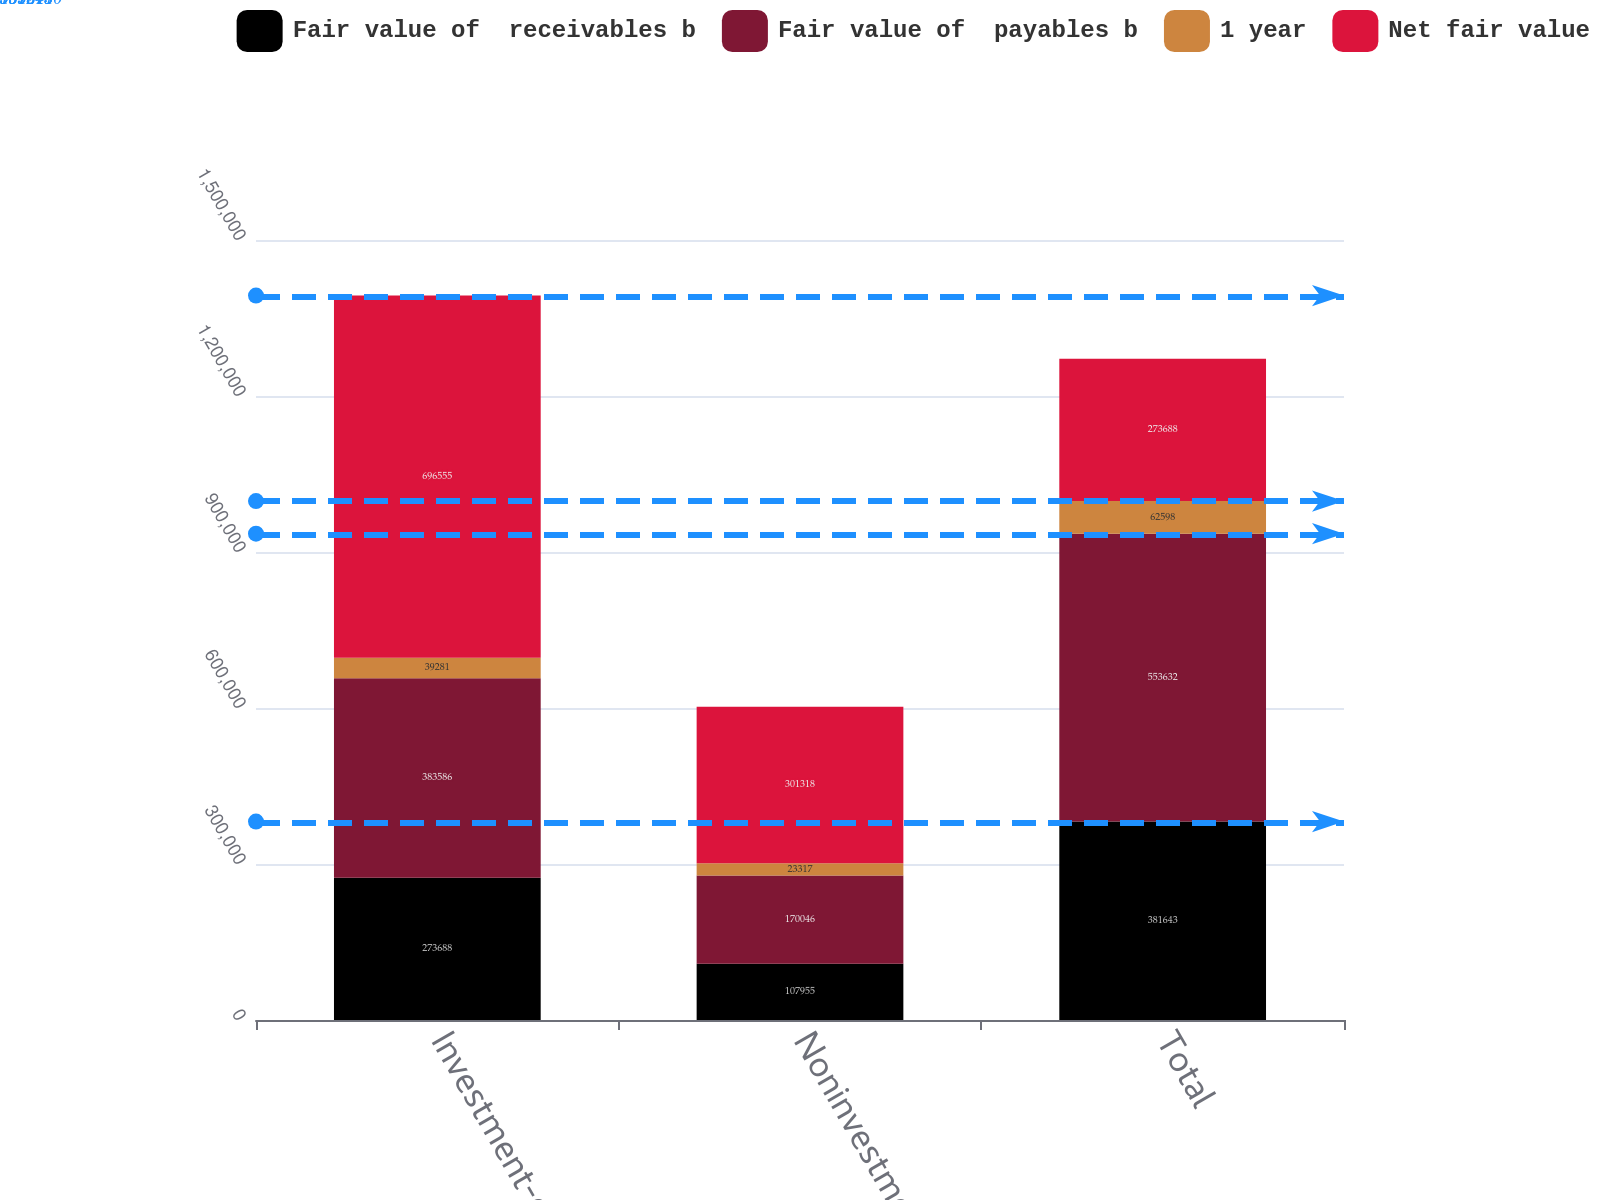<chart> <loc_0><loc_0><loc_500><loc_500><stacked_bar_chart><ecel><fcel>Investment-grade<fcel>Noninvestment-grade<fcel>Total<nl><fcel>Fair value of  receivables b<fcel>273688<fcel>107955<fcel>381643<nl><fcel>Fair value of  payables b<fcel>383586<fcel>170046<fcel>553632<nl><fcel>1 year<fcel>39281<fcel>23317<fcel>62598<nl><fcel>Net fair value<fcel>696555<fcel>301318<fcel>273688<nl></chart> 